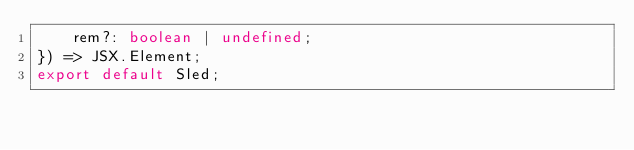Convert code to text. <code><loc_0><loc_0><loc_500><loc_500><_TypeScript_>    rem?: boolean | undefined;
}) => JSX.Element;
export default Sled;
</code> 